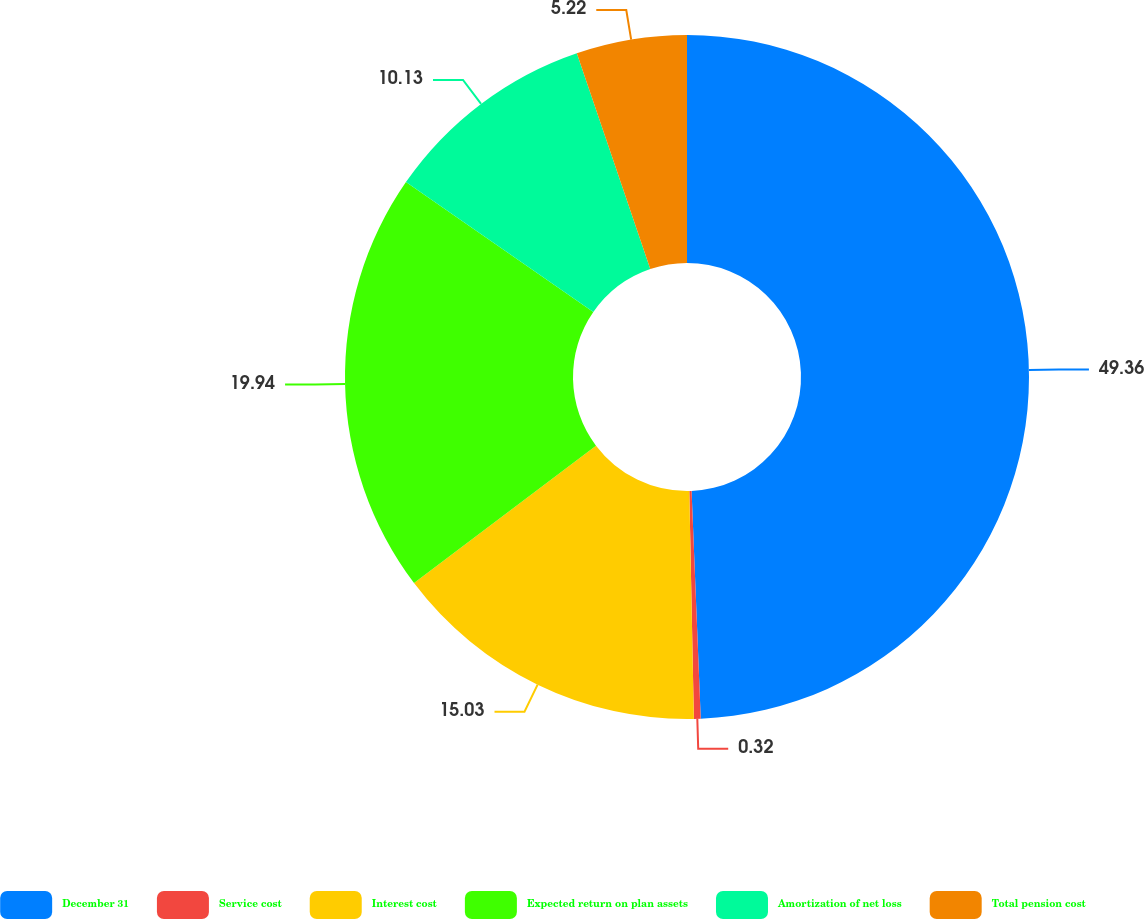Convert chart to OTSL. <chart><loc_0><loc_0><loc_500><loc_500><pie_chart><fcel>December 31<fcel>Service cost<fcel>Interest cost<fcel>Expected return on plan assets<fcel>Amortization of net loss<fcel>Total pension cost<nl><fcel>49.36%<fcel>0.32%<fcel>15.03%<fcel>19.94%<fcel>10.13%<fcel>5.22%<nl></chart> 